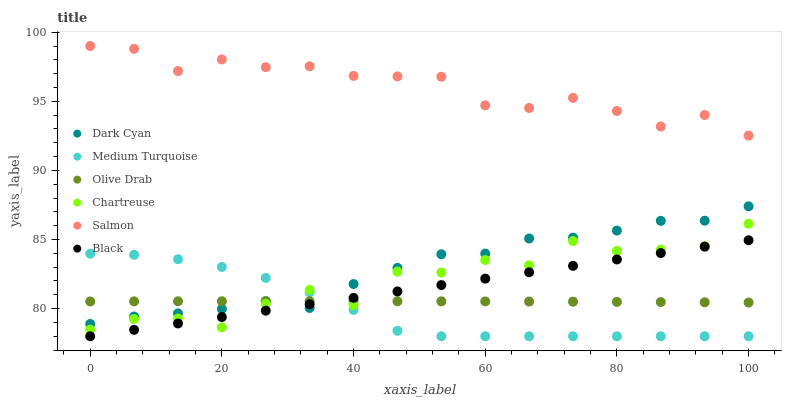Does Medium Turquoise have the minimum area under the curve?
Answer yes or no. Yes. Does Salmon have the maximum area under the curve?
Answer yes or no. Yes. Does Chartreuse have the minimum area under the curve?
Answer yes or no. No. Does Chartreuse have the maximum area under the curve?
Answer yes or no. No. Is Black the smoothest?
Answer yes or no. Yes. Is Chartreuse the roughest?
Answer yes or no. Yes. Is Chartreuse the smoothest?
Answer yes or no. No. Is Black the roughest?
Answer yes or no. No. Does Black have the lowest value?
Answer yes or no. Yes. Does Chartreuse have the lowest value?
Answer yes or no. No. Does Salmon have the highest value?
Answer yes or no. Yes. Does Chartreuse have the highest value?
Answer yes or no. No. Is Dark Cyan less than Salmon?
Answer yes or no. Yes. Is Salmon greater than Olive Drab?
Answer yes or no. Yes. Does Chartreuse intersect Black?
Answer yes or no. Yes. Is Chartreuse less than Black?
Answer yes or no. No. Is Chartreuse greater than Black?
Answer yes or no. No. Does Dark Cyan intersect Salmon?
Answer yes or no. No. 